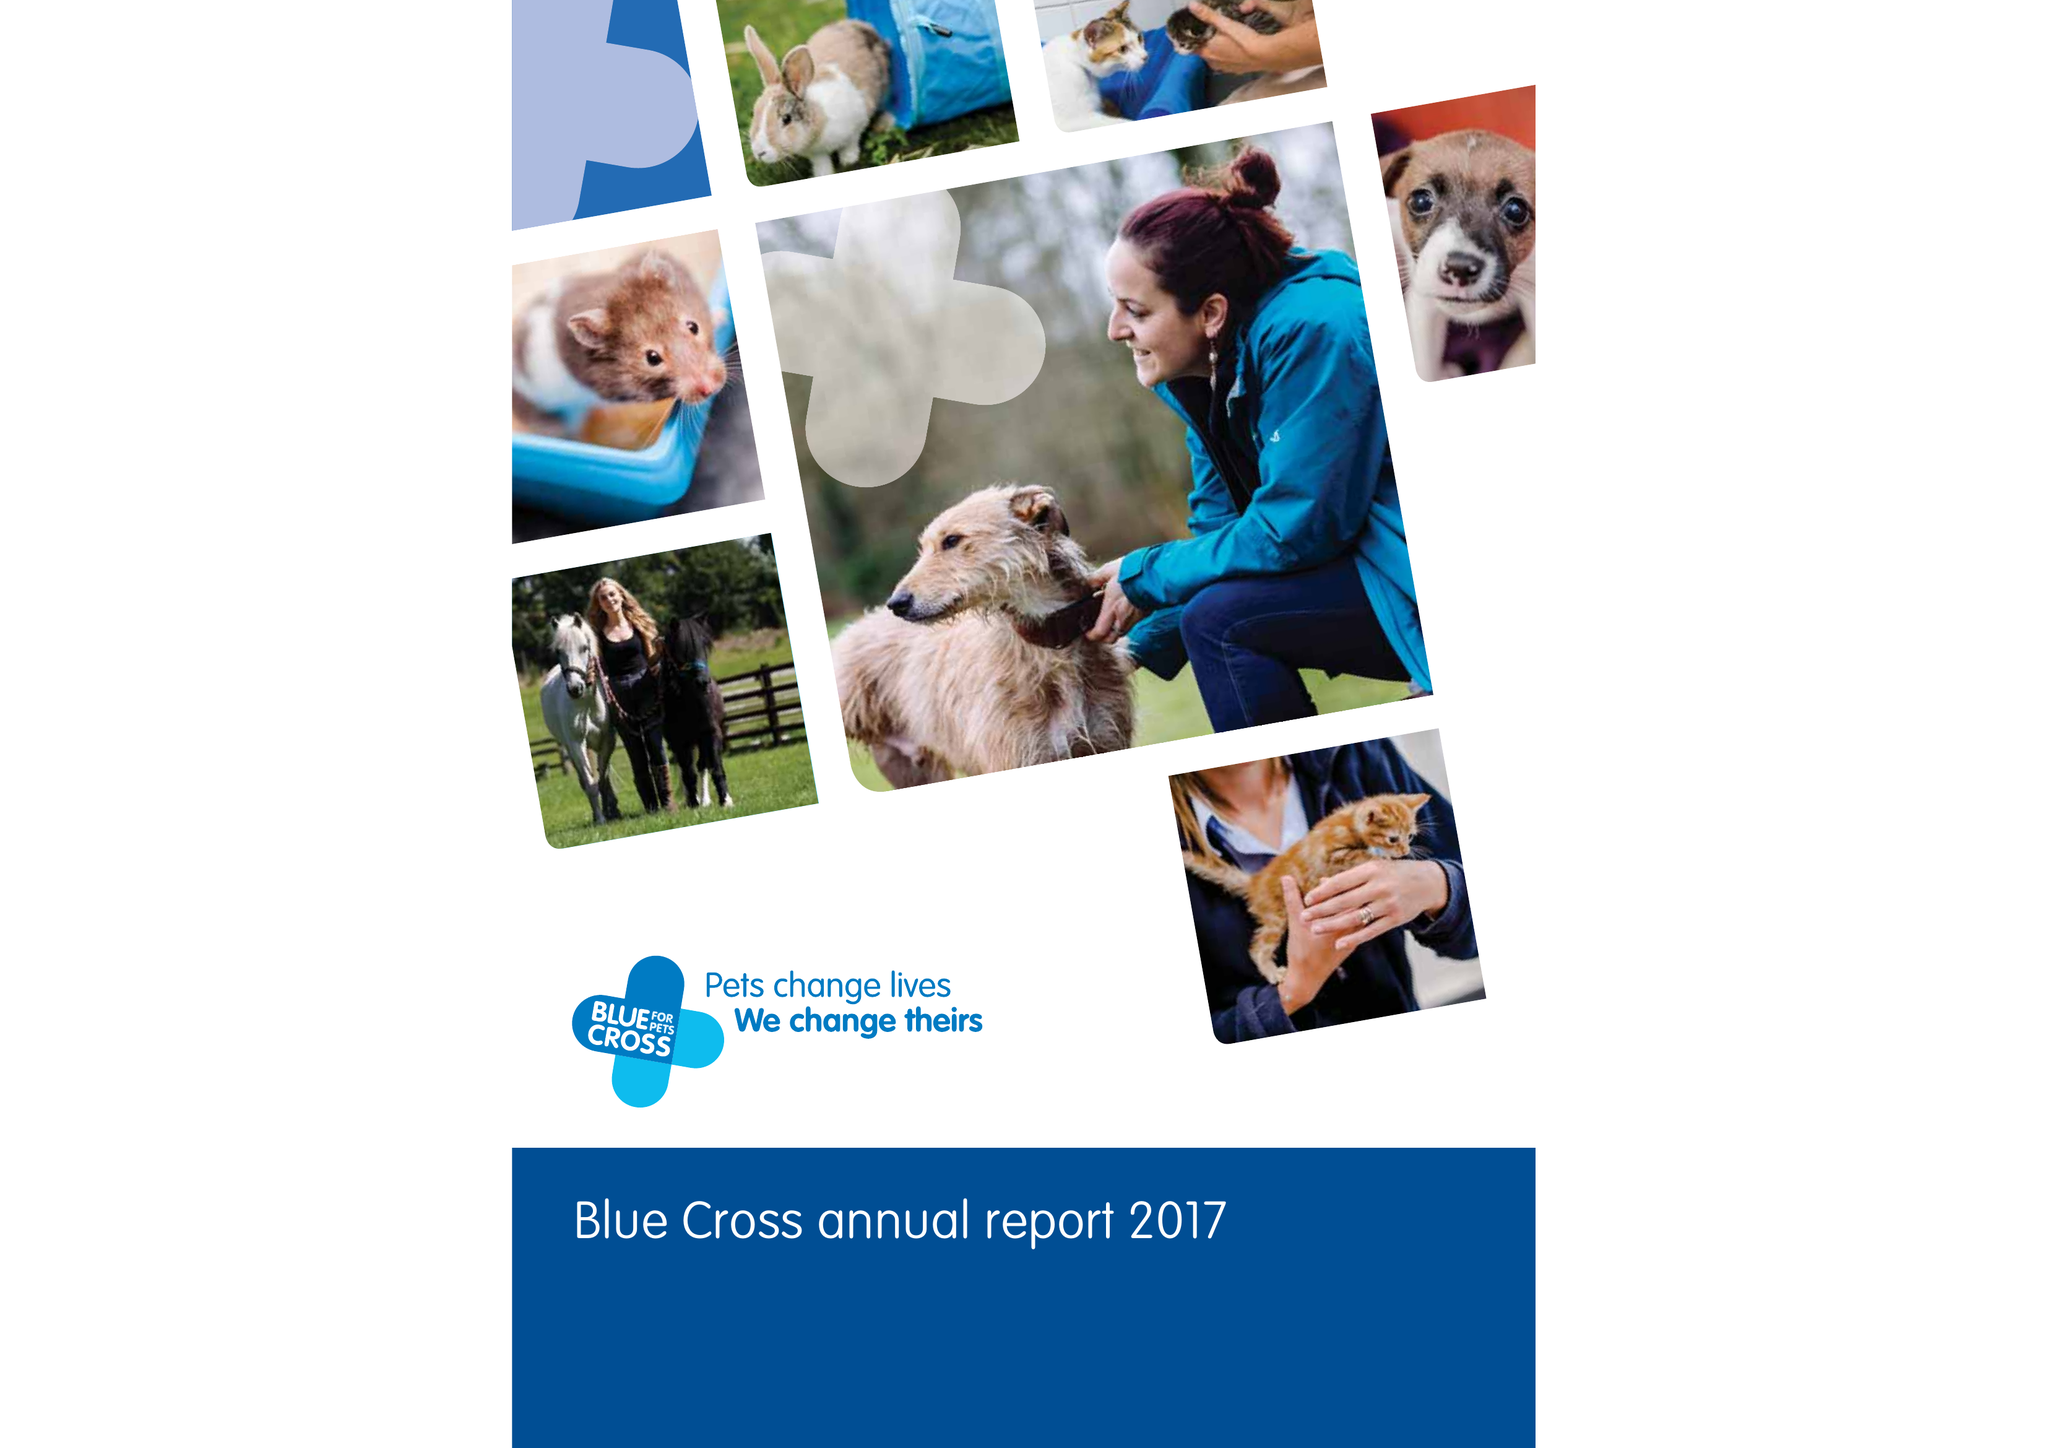What is the value for the address__post_town?
Answer the question using a single word or phrase. CARTERTON 